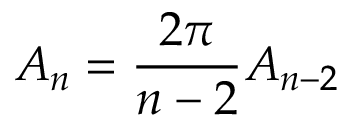Convert formula to latex. <formula><loc_0><loc_0><loc_500><loc_500>A _ { n } = { \frac { 2 \pi } { n - 2 } } A _ { n - 2 }</formula> 